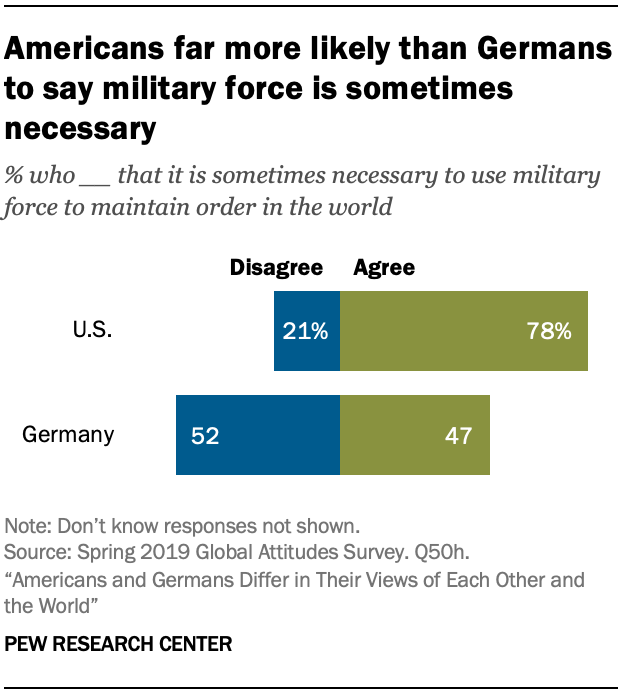Outline some significant characteristics in this image. The average percentage of the U.S. and Germany Agree section is 0.625. The biggest section in the U.S. bar is called. 